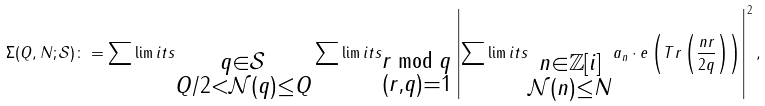Convert formula to latex. <formula><loc_0><loc_0><loc_500><loc_500>\Sigma ( Q , N ; \mathcal { S } ) \colon = \sum \lim i t s _ { \substack { q \in \mathcal { S } \\ Q / 2 < \mathcal { N } ( q ) \leq Q } } \sum \lim i t s _ { \substack { r \bmod { q } \\ ( r , q ) = 1 } } \left | \sum \lim i t s _ { \substack { n \in \mathbb { Z } [ i ] \\ \mathcal { N } ( n ) \leq N } } a _ { n } \cdot e \left ( T r \left ( \frac { n r } { 2 q } \right ) \right ) \right | ^ { 2 } ,</formula> 